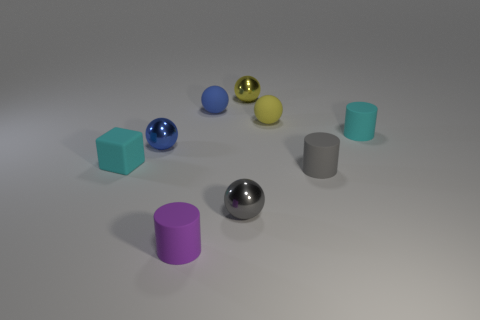What is the material of the cylinder that is the same color as the tiny cube?
Give a very brief answer. Rubber. There is a tiny gray thing in front of the tiny gray rubber cylinder; does it have the same shape as the cyan rubber object that is right of the small rubber cube?
Provide a short and direct response. No. How many cyan things are to the right of the tiny purple matte thing and to the left of the gray metallic ball?
Keep it short and to the point. 0. Are there any big metallic spheres of the same color as the rubber cube?
Ensure brevity in your answer.  No. What is the shape of the yellow rubber object that is the same size as the purple cylinder?
Your answer should be very brief. Sphere. There is a tiny cyan rubber block; are there any tiny metal spheres in front of it?
Ensure brevity in your answer.  Yes. Are the cyan thing left of the small cyan rubber cylinder and the small blue object behind the cyan cylinder made of the same material?
Your response must be concise. Yes. What number of matte spheres are the same size as the block?
Offer a terse response. 2. What is the material of the tiny yellow object that is in front of the blue rubber ball?
Make the answer very short. Rubber. How many other purple matte things have the same shape as the tiny purple thing?
Your answer should be very brief. 0. 